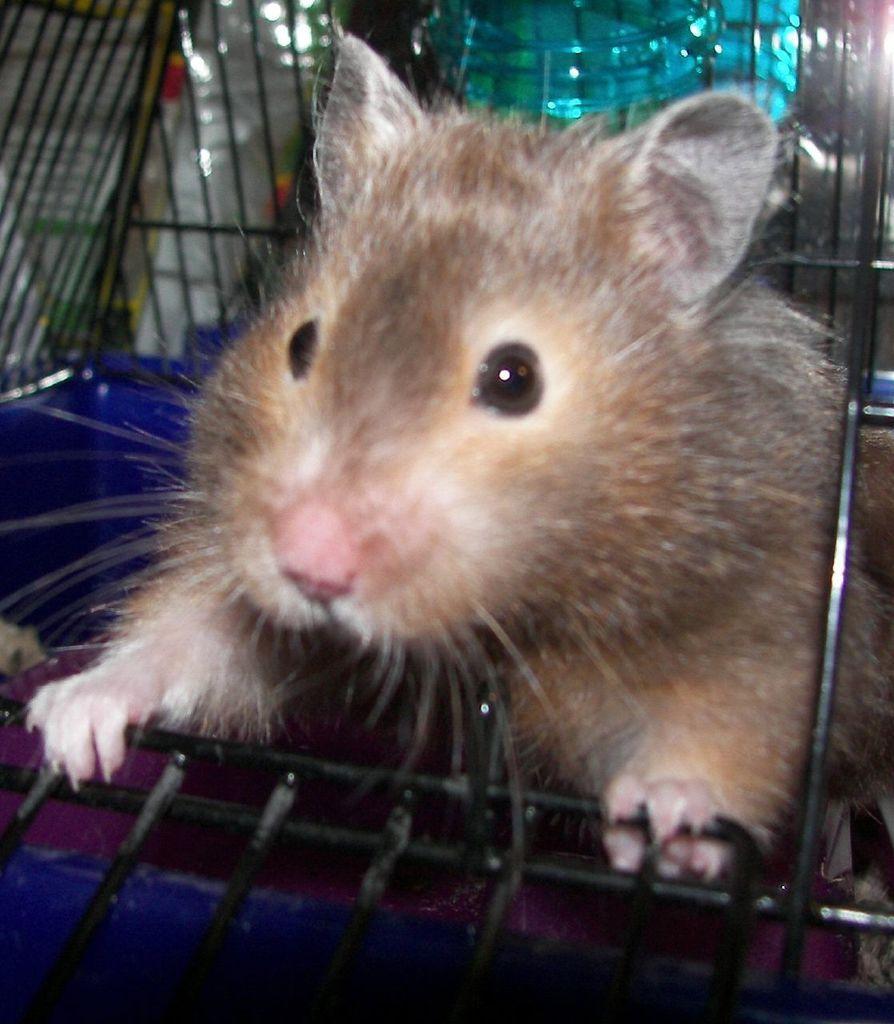In one or two sentences, can you explain what this image depicts? In the image I can see a rat which is in the cage. 